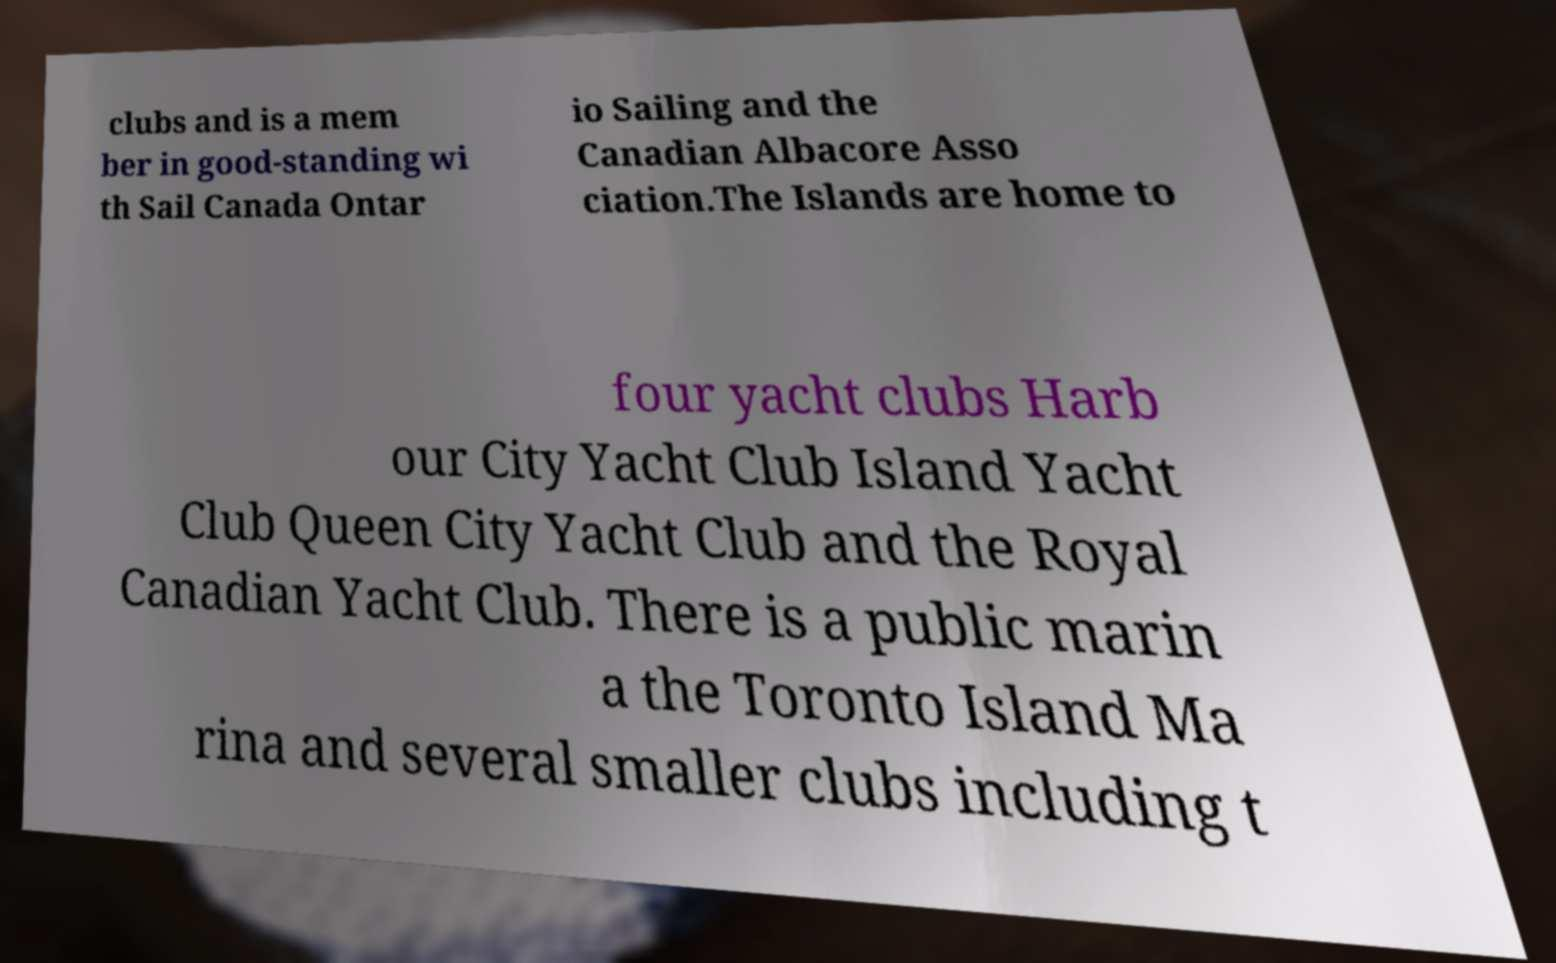Can you accurately transcribe the text from the provided image for me? clubs and is a mem ber in good-standing wi th Sail Canada Ontar io Sailing and the Canadian Albacore Asso ciation.The Islands are home to four yacht clubs Harb our City Yacht Club Island Yacht Club Queen City Yacht Club and the Royal Canadian Yacht Club. There is a public marin a the Toronto Island Ma rina and several smaller clubs including t 